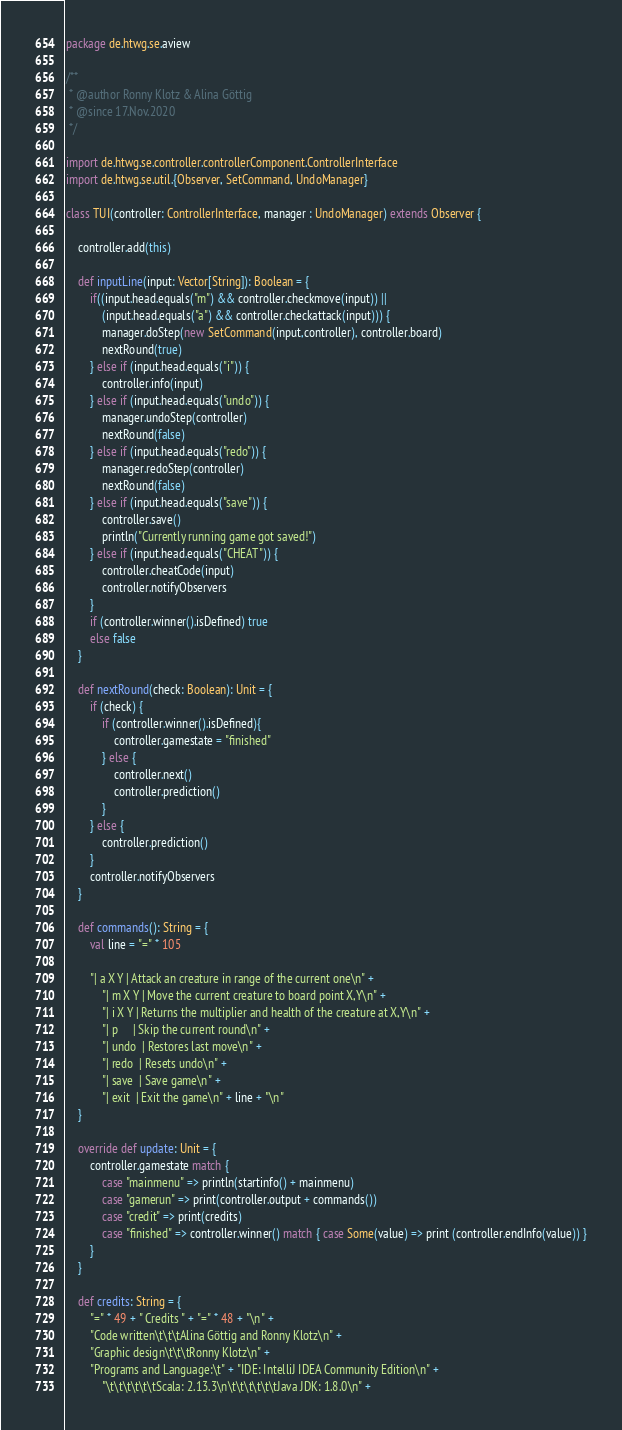<code> <loc_0><loc_0><loc_500><loc_500><_Scala_>package de.htwg.se.aview

/**
 * @author Ronny Klotz & Alina Göttig
 * @since 17.Nov.2020
 */

import de.htwg.se.controller.controllerComponent.ControllerInterface
import de.htwg.se.util.{Observer, SetCommand, UndoManager}

class TUI(controller: ControllerInterface, manager : UndoManager) extends Observer {

    controller.add(this)

    def inputLine(input: Vector[String]): Boolean = {
        if((input.head.equals("m") && controller.checkmove(input)) ||
            (input.head.equals("a") && controller.checkattack(input))) {
            manager.doStep(new SetCommand(input,controller), controller.board)
            nextRound(true)
        } else if (input.head.equals("i")) {
            controller.info(input)
        } else if (input.head.equals("undo")) {
            manager.undoStep(controller)
            nextRound(false)
        } else if (input.head.equals("redo")) {
            manager.redoStep(controller)
            nextRound(false)
        } else if (input.head.equals("save")) {
            controller.save()
            println("Currently running game got saved!")
        } else if (input.head.equals("CHEAT")) {
            controller.cheatCode(input)
            controller.notifyObservers
        }
        if (controller.winner().isDefined) true
        else false
    }

    def nextRound(check: Boolean): Unit = {
        if (check) {
            if (controller.winner().isDefined){
                controller.gamestate = "finished"
            } else {
                controller.next()
                controller.prediction()
            }
        } else {
            controller.prediction()
        }
        controller.notifyObservers
    }

    def commands(): String = {
        val line = "=" * 105

        "| a X Y | Attack an creature in range of the current one\n" +
            "| m X Y | Move the current creature to board point X,Y\n" +
            "| i X Y | Returns the multiplier and health of the creature at X,Y\n" +
            "| p     | Skip the current round\n" +
            "| undo  | Restores last move\n" +
            "| redo  | Resets undo\n" +
            "| save  | Save game\n" +
            "| exit  | Exit the game\n" + line + "\n"
    }

    override def update: Unit = {
        controller.gamestate match {
            case "mainmenu" => println(startinfo() + mainmenu)
            case "gamerun" => print(controller.output + commands())
            case "credit" => print(credits)
            case "finished" => controller.winner() match { case Some(value) => print (controller.endInfo(value)) }
        }
    }

    def credits: String = {
        "=" * 49 + " Credits " + "=" * 48 + "\n" +
        "Code written\t\t\tAlina Göttig and Ronny Klotz\n" +
        "Graphic design\t\t\tRonny Klotz\n" +
        "Programs and Language:\t" + "IDE: IntelliJ IDEA Community Edition\n" +
            "\t\t\t\t\t\tScala: 2.13.3\n\t\t\t\t\t\tJava JDK: 1.8.0\n" +</code> 